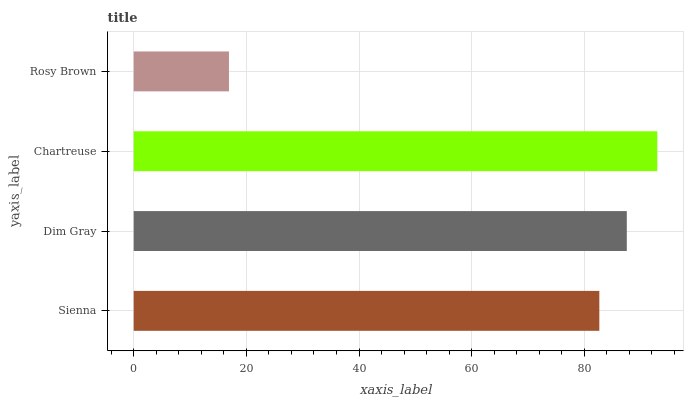Is Rosy Brown the minimum?
Answer yes or no. Yes. Is Chartreuse the maximum?
Answer yes or no. Yes. Is Dim Gray the minimum?
Answer yes or no. No. Is Dim Gray the maximum?
Answer yes or no. No. Is Dim Gray greater than Sienna?
Answer yes or no. Yes. Is Sienna less than Dim Gray?
Answer yes or no. Yes. Is Sienna greater than Dim Gray?
Answer yes or no. No. Is Dim Gray less than Sienna?
Answer yes or no. No. Is Dim Gray the high median?
Answer yes or no. Yes. Is Sienna the low median?
Answer yes or no. Yes. Is Sienna the high median?
Answer yes or no. No. Is Dim Gray the low median?
Answer yes or no. No. 